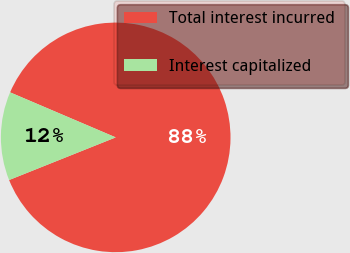Convert chart to OTSL. <chart><loc_0><loc_0><loc_500><loc_500><pie_chart><fcel>Total interest incurred<fcel>Interest capitalized<nl><fcel>87.53%<fcel>12.47%<nl></chart> 